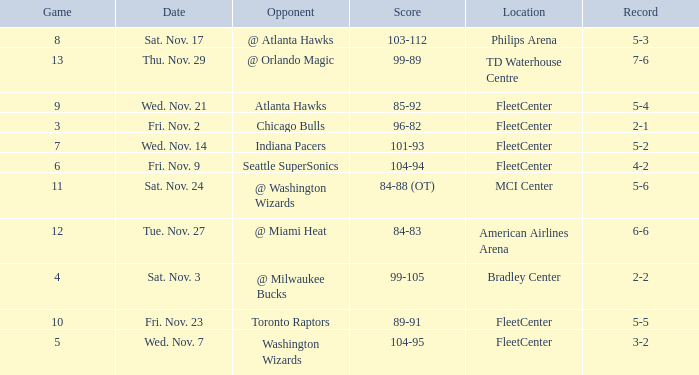What is the earliest game with a score of 99-89? 13.0. 